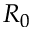<formula> <loc_0><loc_0><loc_500><loc_500>R _ { 0 }</formula> 